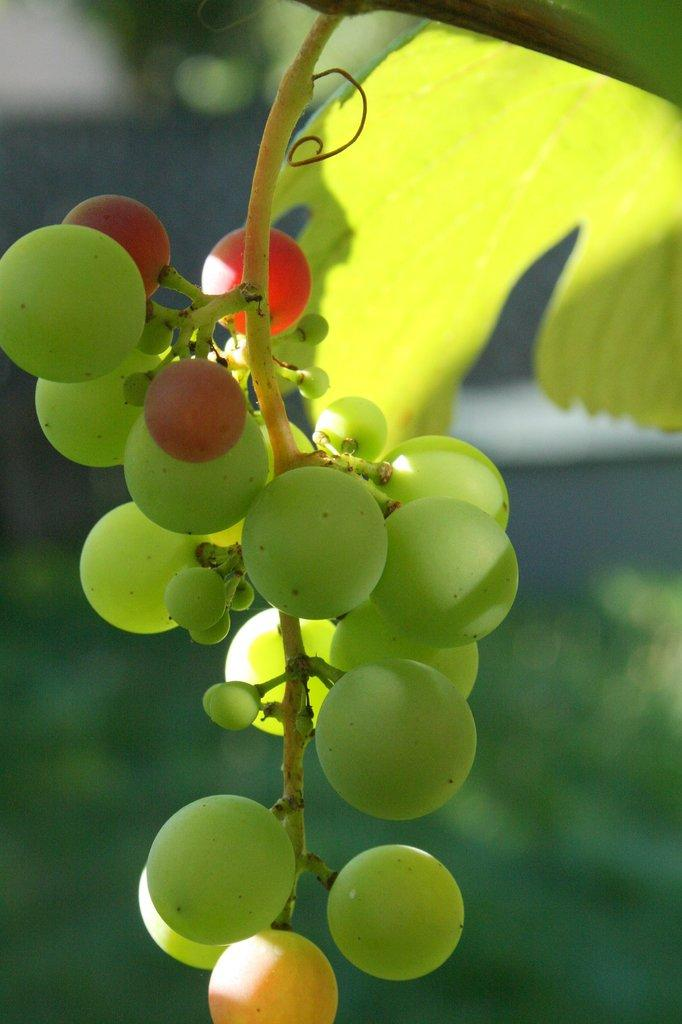What type of objects are in the image? There is a group of fruits in the image. Can you describe the background of the image? There is a leaf in the background of the image. What type of chess pieces can be seen in the image? There are no chess pieces present in the image; it features a group of fruits and a leaf in the background. What color is the orange in the image? There is no orange present in the image; it features a group of fruits and a leaf in the background. 